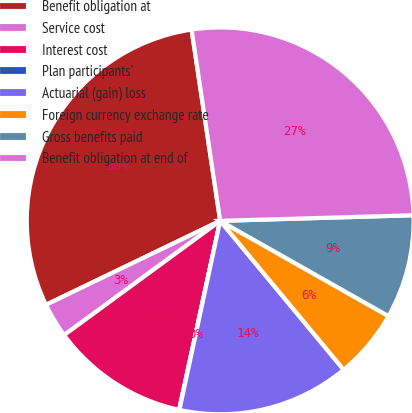Convert chart to OTSL. <chart><loc_0><loc_0><loc_500><loc_500><pie_chart><fcel>Benefit obligation at<fcel>Service cost<fcel>Interest cost<fcel>Plan participants'<fcel>Actuarial (gain) loss<fcel>Foreign currency exchange rate<fcel>Gross benefits paid<fcel>Benefit obligation at end of<nl><fcel>29.78%<fcel>2.91%<fcel>11.53%<fcel>0.03%<fcel>14.4%<fcel>5.78%<fcel>8.66%<fcel>26.9%<nl></chart> 